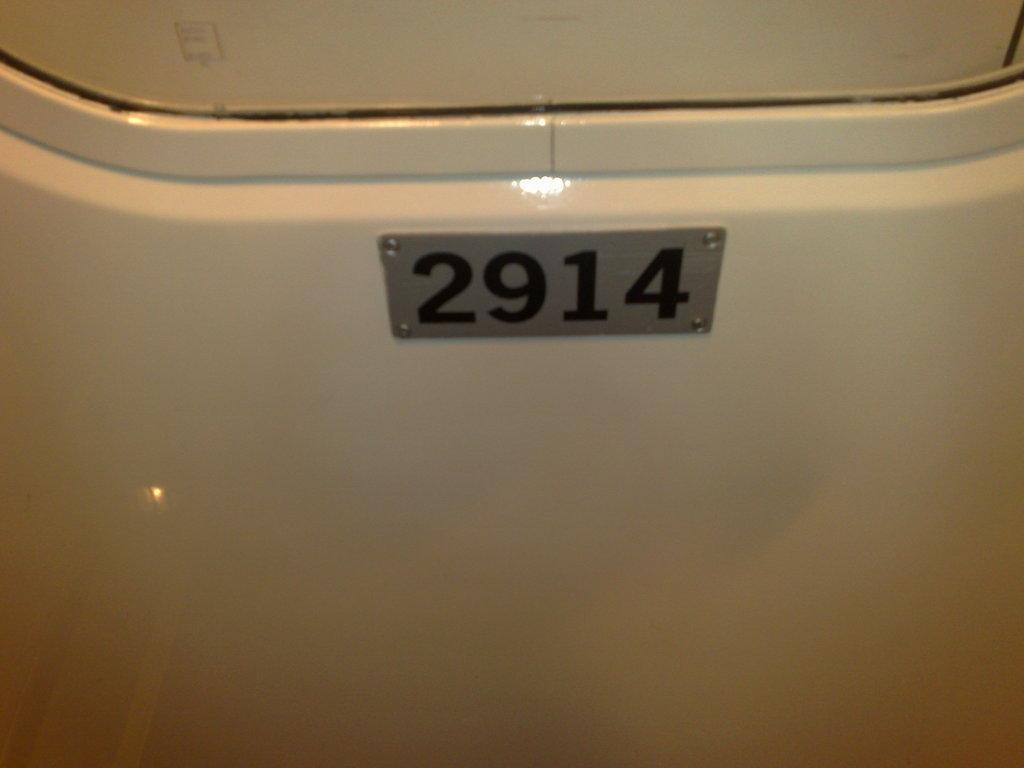Describe this image in one or two sentences. The picture has white surface. In the center of the picture there is a number plate. 